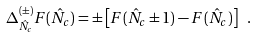<formula> <loc_0><loc_0><loc_500><loc_500>\Delta _ { { \hat { N } } _ { c } } ^ { ( \pm ) } F ( { \hat { N } } _ { c } ) = \pm \left [ F ( { \hat { N } } _ { c } \pm 1 ) - F ( { \hat { N } } _ { c } ) \right ] \ .</formula> 